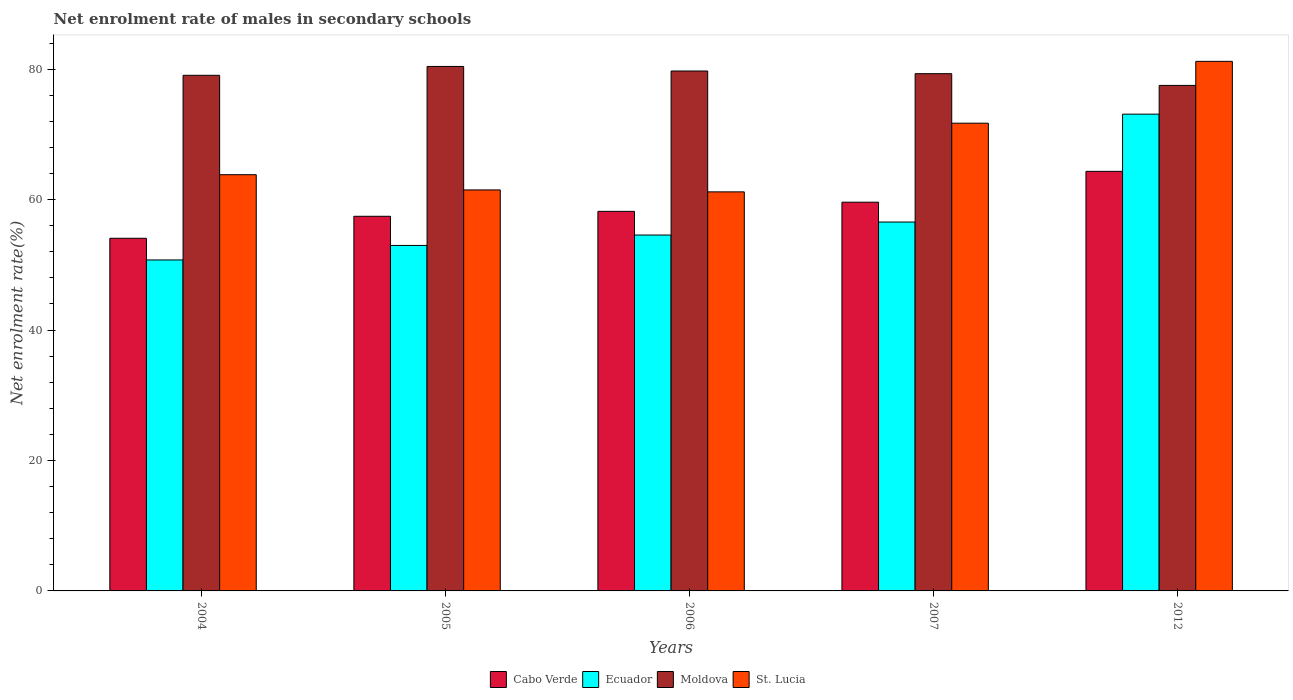Are the number of bars per tick equal to the number of legend labels?
Your answer should be compact. Yes. Are the number of bars on each tick of the X-axis equal?
Keep it short and to the point. Yes. How many bars are there on the 2nd tick from the left?
Give a very brief answer. 4. How many bars are there on the 2nd tick from the right?
Provide a succinct answer. 4. What is the label of the 4th group of bars from the left?
Keep it short and to the point. 2007. What is the net enrolment rate of males in secondary schools in St. Lucia in 2012?
Keep it short and to the point. 81.19. Across all years, what is the maximum net enrolment rate of males in secondary schools in Cabo Verde?
Your response must be concise. 64.33. Across all years, what is the minimum net enrolment rate of males in secondary schools in Moldova?
Your answer should be compact. 77.5. In which year was the net enrolment rate of males in secondary schools in Ecuador maximum?
Keep it short and to the point. 2012. In which year was the net enrolment rate of males in secondary schools in Cabo Verde minimum?
Provide a short and direct response. 2004. What is the total net enrolment rate of males in secondary schools in St. Lucia in the graph?
Provide a short and direct response. 339.38. What is the difference between the net enrolment rate of males in secondary schools in Moldova in 2005 and that in 2006?
Give a very brief answer. 0.7. What is the difference between the net enrolment rate of males in secondary schools in Ecuador in 2007 and the net enrolment rate of males in secondary schools in St. Lucia in 2006?
Give a very brief answer. -4.63. What is the average net enrolment rate of males in secondary schools in Moldova per year?
Offer a very short reply. 79.2. In the year 2007, what is the difference between the net enrolment rate of males in secondary schools in Cabo Verde and net enrolment rate of males in secondary schools in Moldova?
Give a very brief answer. -19.7. What is the ratio of the net enrolment rate of males in secondary schools in Moldova in 2004 to that in 2006?
Give a very brief answer. 0.99. What is the difference between the highest and the second highest net enrolment rate of males in secondary schools in Cabo Verde?
Your response must be concise. 4.73. What is the difference between the highest and the lowest net enrolment rate of males in secondary schools in Moldova?
Give a very brief answer. 2.91. Is the sum of the net enrolment rate of males in secondary schools in Cabo Verde in 2006 and 2012 greater than the maximum net enrolment rate of males in secondary schools in Ecuador across all years?
Provide a short and direct response. Yes. What does the 2nd bar from the left in 2007 represents?
Keep it short and to the point. Ecuador. What does the 3rd bar from the right in 2005 represents?
Keep it short and to the point. Ecuador. Is it the case that in every year, the sum of the net enrolment rate of males in secondary schools in Ecuador and net enrolment rate of males in secondary schools in Cabo Verde is greater than the net enrolment rate of males in secondary schools in St. Lucia?
Offer a very short reply. Yes. How many bars are there?
Provide a succinct answer. 20. Are all the bars in the graph horizontal?
Provide a short and direct response. No. Does the graph contain any zero values?
Keep it short and to the point. No. How many legend labels are there?
Keep it short and to the point. 4. What is the title of the graph?
Offer a very short reply. Net enrolment rate of males in secondary schools. What is the label or title of the Y-axis?
Make the answer very short. Net enrolment rate(%). What is the Net enrolment rate(%) of Cabo Verde in 2004?
Your answer should be very brief. 54.07. What is the Net enrolment rate(%) in Ecuador in 2004?
Offer a terse response. 50.74. What is the Net enrolment rate(%) in Moldova in 2004?
Keep it short and to the point. 79.05. What is the Net enrolment rate(%) of St. Lucia in 2004?
Give a very brief answer. 63.81. What is the Net enrolment rate(%) of Cabo Verde in 2005?
Your answer should be compact. 57.44. What is the Net enrolment rate(%) in Ecuador in 2005?
Provide a succinct answer. 52.97. What is the Net enrolment rate(%) of Moldova in 2005?
Offer a very short reply. 80.41. What is the Net enrolment rate(%) of St. Lucia in 2005?
Keep it short and to the point. 61.48. What is the Net enrolment rate(%) in Cabo Verde in 2006?
Your response must be concise. 58.19. What is the Net enrolment rate(%) of Ecuador in 2006?
Provide a short and direct response. 54.56. What is the Net enrolment rate(%) in Moldova in 2006?
Your answer should be compact. 79.71. What is the Net enrolment rate(%) of St. Lucia in 2006?
Your answer should be very brief. 61.18. What is the Net enrolment rate(%) in Cabo Verde in 2007?
Ensure brevity in your answer.  59.6. What is the Net enrolment rate(%) of Ecuador in 2007?
Your answer should be compact. 56.56. What is the Net enrolment rate(%) of Moldova in 2007?
Give a very brief answer. 79.3. What is the Net enrolment rate(%) of St. Lucia in 2007?
Your answer should be very brief. 71.71. What is the Net enrolment rate(%) of Cabo Verde in 2012?
Your answer should be compact. 64.33. What is the Net enrolment rate(%) in Ecuador in 2012?
Provide a short and direct response. 73.1. What is the Net enrolment rate(%) of Moldova in 2012?
Offer a terse response. 77.5. What is the Net enrolment rate(%) of St. Lucia in 2012?
Offer a very short reply. 81.19. Across all years, what is the maximum Net enrolment rate(%) of Cabo Verde?
Give a very brief answer. 64.33. Across all years, what is the maximum Net enrolment rate(%) in Ecuador?
Your answer should be very brief. 73.1. Across all years, what is the maximum Net enrolment rate(%) of Moldova?
Your answer should be very brief. 80.41. Across all years, what is the maximum Net enrolment rate(%) of St. Lucia?
Offer a terse response. 81.19. Across all years, what is the minimum Net enrolment rate(%) in Cabo Verde?
Your answer should be compact. 54.07. Across all years, what is the minimum Net enrolment rate(%) in Ecuador?
Your answer should be compact. 50.74. Across all years, what is the minimum Net enrolment rate(%) of Moldova?
Keep it short and to the point. 77.5. Across all years, what is the minimum Net enrolment rate(%) of St. Lucia?
Keep it short and to the point. 61.18. What is the total Net enrolment rate(%) in Cabo Verde in the graph?
Give a very brief answer. 293.62. What is the total Net enrolment rate(%) of Ecuador in the graph?
Keep it short and to the point. 287.93. What is the total Net enrolment rate(%) of Moldova in the graph?
Ensure brevity in your answer.  395.98. What is the total Net enrolment rate(%) of St. Lucia in the graph?
Offer a very short reply. 339.38. What is the difference between the Net enrolment rate(%) in Cabo Verde in 2004 and that in 2005?
Ensure brevity in your answer.  -3.37. What is the difference between the Net enrolment rate(%) of Ecuador in 2004 and that in 2005?
Ensure brevity in your answer.  -2.23. What is the difference between the Net enrolment rate(%) of Moldova in 2004 and that in 2005?
Keep it short and to the point. -1.36. What is the difference between the Net enrolment rate(%) of St. Lucia in 2004 and that in 2005?
Offer a very short reply. 2.33. What is the difference between the Net enrolment rate(%) in Cabo Verde in 2004 and that in 2006?
Offer a terse response. -4.13. What is the difference between the Net enrolment rate(%) in Ecuador in 2004 and that in 2006?
Provide a succinct answer. -3.82. What is the difference between the Net enrolment rate(%) of Moldova in 2004 and that in 2006?
Ensure brevity in your answer.  -0.66. What is the difference between the Net enrolment rate(%) of St. Lucia in 2004 and that in 2006?
Give a very brief answer. 2.63. What is the difference between the Net enrolment rate(%) in Cabo Verde in 2004 and that in 2007?
Your response must be concise. -5.53. What is the difference between the Net enrolment rate(%) of Ecuador in 2004 and that in 2007?
Your response must be concise. -5.81. What is the difference between the Net enrolment rate(%) in Moldova in 2004 and that in 2007?
Make the answer very short. -0.25. What is the difference between the Net enrolment rate(%) in St. Lucia in 2004 and that in 2007?
Your answer should be very brief. -7.9. What is the difference between the Net enrolment rate(%) of Cabo Verde in 2004 and that in 2012?
Provide a succinct answer. -10.26. What is the difference between the Net enrolment rate(%) in Ecuador in 2004 and that in 2012?
Ensure brevity in your answer.  -22.35. What is the difference between the Net enrolment rate(%) of Moldova in 2004 and that in 2012?
Keep it short and to the point. 1.55. What is the difference between the Net enrolment rate(%) of St. Lucia in 2004 and that in 2012?
Provide a short and direct response. -17.38. What is the difference between the Net enrolment rate(%) of Cabo Verde in 2005 and that in 2006?
Your answer should be compact. -0.76. What is the difference between the Net enrolment rate(%) of Ecuador in 2005 and that in 2006?
Give a very brief answer. -1.59. What is the difference between the Net enrolment rate(%) in Moldova in 2005 and that in 2006?
Ensure brevity in your answer.  0.7. What is the difference between the Net enrolment rate(%) of St. Lucia in 2005 and that in 2006?
Give a very brief answer. 0.3. What is the difference between the Net enrolment rate(%) of Cabo Verde in 2005 and that in 2007?
Provide a short and direct response. -2.16. What is the difference between the Net enrolment rate(%) of Ecuador in 2005 and that in 2007?
Your answer should be very brief. -3.59. What is the difference between the Net enrolment rate(%) of Moldova in 2005 and that in 2007?
Provide a succinct answer. 1.11. What is the difference between the Net enrolment rate(%) in St. Lucia in 2005 and that in 2007?
Your answer should be very brief. -10.23. What is the difference between the Net enrolment rate(%) in Cabo Verde in 2005 and that in 2012?
Your answer should be very brief. -6.89. What is the difference between the Net enrolment rate(%) in Ecuador in 2005 and that in 2012?
Your response must be concise. -20.13. What is the difference between the Net enrolment rate(%) in Moldova in 2005 and that in 2012?
Offer a terse response. 2.91. What is the difference between the Net enrolment rate(%) in St. Lucia in 2005 and that in 2012?
Ensure brevity in your answer.  -19.71. What is the difference between the Net enrolment rate(%) of Cabo Verde in 2006 and that in 2007?
Keep it short and to the point. -1.4. What is the difference between the Net enrolment rate(%) of Ecuador in 2006 and that in 2007?
Provide a short and direct response. -1.99. What is the difference between the Net enrolment rate(%) of Moldova in 2006 and that in 2007?
Make the answer very short. 0.41. What is the difference between the Net enrolment rate(%) in St. Lucia in 2006 and that in 2007?
Your response must be concise. -10.53. What is the difference between the Net enrolment rate(%) of Cabo Verde in 2006 and that in 2012?
Provide a succinct answer. -6.13. What is the difference between the Net enrolment rate(%) in Ecuador in 2006 and that in 2012?
Offer a terse response. -18.54. What is the difference between the Net enrolment rate(%) of Moldova in 2006 and that in 2012?
Provide a short and direct response. 2.21. What is the difference between the Net enrolment rate(%) of St. Lucia in 2006 and that in 2012?
Keep it short and to the point. -20.01. What is the difference between the Net enrolment rate(%) of Cabo Verde in 2007 and that in 2012?
Offer a very short reply. -4.73. What is the difference between the Net enrolment rate(%) of Ecuador in 2007 and that in 2012?
Ensure brevity in your answer.  -16.54. What is the difference between the Net enrolment rate(%) in Moldova in 2007 and that in 2012?
Make the answer very short. 1.8. What is the difference between the Net enrolment rate(%) in St. Lucia in 2007 and that in 2012?
Provide a succinct answer. -9.48. What is the difference between the Net enrolment rate(%) of Cabo Verde in 2004 and the Net enrolment rate(%) of Ecuador in 2005?
Your answer should be compact. 1.1. What is the difference between the Net enrolment rate(%) in Cabo Verde in 2004 and the Net enrolment rate(%) in Moldova in 2005?
Ensure brevity in your answer.  -26.34. What is the difference between the Net enrolment rate(%) of Cabo Verde in 2004 and the Net enrolment rate(%) of St. Lucia in 2005?
Provide a succinct answer. -7.41. What is the difference between the Net enrolment rate(%) of Ecuador in 2004 and the Net enrolment rate(%) of Moldova in 2005?
Provide a succinct answer. -29.67. What is the difference between the Net enrolment rate(%) of Ecuador in 2004 and the Net enrolment rate(%) of St. Lucia in 2005?
Provide a succinct answer. -10.74. What is the difference between the Net enrolment rate(%) of Moldova in 2004 and the Net enrolment rate(%) of St. Lucia in 2005?
Provide a succinct answer. 17.57. What is the difference between the Net enrolment rate(%) in Cabo Verde in 2004 and the Net enrolment rate(%) in Ecuador in 2006?
Provide a succinct answer. -0.5. What is the difference between the Net enrolment rate(%) in Cabo Verde in 2004 and the Net enrolment rate(%) in Moldova in 2006?
Your answer should be compact. -25.64. What is the difference between the Net enrolment rate(%) of Cabo Verde in 2004 and the Net enrolment rate(%) of St. Lucia in 2006?
Your answer should be compact. -7.12. What is the difference between the Net enrolment rate(%) in Ecuador in 2004 and the Net enrolment rate(%) in Moldova in 2006?
Your answer should be compact. -28.97. What is the difference between the Net enrolment rate(%) in Ecuador in 2004 and the Net enrolment rate(%) in St. Lucia in 2006?
Keep it short and to the point. -10.44. What is the difference between the Net enrolment rate(%) of Moldova in 2004 and the Net enrolment rate(%) of St. Lucia in 2006?
Offer a terse response. 17.87. What is the difference between the Net enrolment rate(%) in Cabo Verde in 2004 and the Net enrolment rate(%) in Ecuador in 2007?
Give a very brief answer. -2.49. What is the difference between the Net enrolment rate(%) in Cabo Verde in 2004 and the Net enrolment rate(%) in Moldova in 2007?
Give a very brief answer. -25.23. What is the difference between the Net enrolment rate(%) of Cabo Verde in 2004 and the Net enrolment rate(%) of St. Lucia in 2007?
Provide a succinct answer. -17.64. What is the difference between the Net enrolment rate(%) in Ecuador in 2004 and the Net enrolment rate(%) in Moldova in 2007?
Provide a short and direct response. -28.56. What is the difference between the Net enrolment rate(%) in Ecuador in 2004 and the Net enrolment rate(%) in St. Lucia in 2007?
Keep it short and to the point. -20.97. What is the difference between the Net enrolment rate(%) in Moldova in 2004 and the Net enrolment rate(%) in St. Lucia in 2007?
Your answer should be very brief. 7.34. What is the difference between the Net enrolment rate(%) of Cabo Verde in 2004 and the Net enrolment rate(%) of Ecuador in 2012?
Provide a short and direct response. -19.03. What is the difference between the Net enrolment rate(%) of Cabo Verde in 2004 and the Net enrolment rate(%) of Moldova in 2012?
Your answer should be very brief. -23.44. What is the difference between the Net enrolment rate(%) in Cabo Verde in 2004 and the Net enrolment rate(%) in St. Lucia in 2012?
Make the answer very short. -27.13. What is the difference between the Net enrolment rate(%) in Ecuador in 2004 and the Net enrolment rate(%) in Moldova in 2012?
Your answer should be compact. -26.76. What is the difference between the Net enrolment rate(%) in Ecuador in 2004 and the Net enrolment rate(%) in St. Lucia in 2012?
Ensure brevity in your answer.  -30.45. What is the difference between the Net enrolment rate(%) of Moldova in 2004 and the Net enrolment rate(%) of St. Lucia in 2012?
Offer a terse response. -2.14. What is the difference between the Net enrolment rate(%) of Cabo Verde in 2005 and the Net enrolment rate(%) of Ecuador in 2006?
Keep it short and to the point. 2.88. What is the difference between the Net enrolment rate(%) in Cabo Verde in 2005 and the Net enrolment rate(%) in Moldova in 2006?
Your answer should be very brief. -22.27. What is the difference between the Net enrolment rate(%) of Cabo Verde in 2005 and the Net enrolment rate(%) of St. Lucia in 2006?
Your response must be concise. -3.75. What is the difference between the Net enrolment rate(%) of Ecuador in 2005 and the Net enrolment rate(%) of Moldova in 2006?
Give a very brief answer. -26.74. What is the difference between the Net enrolment rate(%) of Ecuador in 2005 and the Net enrolment rate(%) of St. Lucia in 2006?
Keep it short and to the point. -8.21. What is the difference between the Net enrolment rate(%) of Moldova in 2005 and the Net enrolment rate(%) of St. Lucia in 2006?
Provide a succinct answer. 19.23. What is the difference between the Net enrolment rate(%) in Cabo Verde in 2005 and the Net enrolment rate(%) in Ecuador in 2007?
Make the answer very short. 0.88. What is the difference between the Net enrolment rate(%) of Cabo Verde in 2005 and the Net enrolment rate(%) of Moldova in 2007?
Provide a short and direct response. -21.86. What is the difference between the Net enrolment rate(%) of Cabo Verde in 2005 and the Net enrolment rate(%) of St. Lucia in 2007?
Provide a succinct answer. -14.27. What is the difference between the Net enrolment rate(%) of Ecuador in 2005 and the Net enrolment rate(%) of Moldova in 2007?
Your answer should be very brief. -26.33. What is the difference between the Net enrolment rate(%) in Ecuador in 2005 and the Net enrolment rate(%) in St. Lucia in 2007?
Your answer should be compact. -18.74. What is the difference between the Net enrolment rate(%) of Moldova in 2005 and the Net enrolment rate(%) of St. Lucia in 2007?
Your answer should be compact. 8.7. What is the difference between the Net enrolment rate(%) in Cabo Verde in 2005 and the Net enrolment rate(%) in Ecuador in 2012?
Offer a very short reply. -15.66. What is the difference between the Net enrolment rate(%) in Cabo Verde in 2005 and the Net enrolment rate(%) in Moldova in 2012?
Give a very brief answer. -20.07. What is the difference between the Net enrolment rate(%) of Cabo Verde in 2005 and the Net enrolment rate(%) of St. Lucia in 2012?
Provide a short and direct response. -23.75. What is the difference between the Net enrolment rate(%) in Ecuador in 2005 and the Net enrolment rate(%) in Moldova in 2012?
Offer a very short reply. -24.53. What is the difference between the Net enrolment rate(%) in Ecuador in 2005 and the Net enrolment rate(%) in St. Lucia in 2012?
Your answer should be compact. -28.22. What is the difference between the Net enrolment rate(%) in Moldova in 2005 and the Net enrolment rate(%) in St. Lucia in 2012?
Your answer should be very brief. -0.78. What is the difference between the Net enrolment rate(%) in Cabo Verde in 2006 and the Net enrolment rate(%) in Ecuador in 2007?
Ensure brevity in your answer.  1.64. What is the difference between the Net enrolment rate(%) of Cabo Verde in 2006 and the Net enrolment rate(%) of Moldova in 2007?
Offer a terse response. -21.11. What is the difference between the Net enrolment rate(%) of Cabo Verde in 2006 and the Net enrolment rate(%) of St. Lucia in 2007?
Keep it short and to the point. -13.52. What is the difference between the Net enrolment rate(%) of Ecuador in 2006 and the Net enrolment rate(%) of Moldova in 2007?
Provide a short and direct response. -24.74. What is the difference between the Net enrolment rate(%) of Ecuador in 2006 and the Net enrolment rate(%) of St. Lucia in 2007?
Your answer should be compact. -17.15. What is the difference between the Net enrolment rate(%) in Moldova in 2006 and the Net enrolment rate(%) in St. Lucia in 2007?
Give a very brief answer. 8. What is the difference between the Net enrolment rate(%) of Cabo Verde in 2006 and the Net enrolment rate(%) of Ecuador in 2012?
Give a very brief answer. -14.9. What is the difference between the Net enrolment rate(%) in Cabo Verde in 2006 and the Net enrolment rate(%) in Moldova in 2012?
Give a very brief answer. -19.31. What is the difference between the Net enrolment rate(%) in Cabo Verde in 2006 and the Net enrolment rate(%) in St. Lucia in 2012?
Make the answer very short. -23. What is the difference between the Net enrolment rate(%) in Ecuador in 2006 and the Net enrolment rate(%) in Moldova in 2012?
Your response must be concise. -22.94. What is the difference between the Net enrolment rate(%) in Ecuador in 2006 and the Net enrolment rate(%) in St. Lucia in 2012?
Your answer should be very brief. -26.63. What is the difference between the Net enrolment rate(%) in Moldova in 2006 and the Net enrolment rate(%) in St. Lucia in 2012?
Your answer should be very brief. -1.48. What is the difference between the Net enrolment rate(%) in Cabo Verde in 2007 and the Net enrolment rate(%) in Ecuador in 2012?
Your answer should be very brief. -13.5. What is the difference between the Net enrolment rate(%) in Cabo Verde in 2007 and the Net enrolment rate(%) in Moldova in 2012?
Your answer should be compact. -17.91. What is the difference between the Net enrolment rate(%) in Cabo Verde in 2007 and the Net enrolment rate(%) in St. Lucia in 2012?
Ensure brevity in your answer.  -21.59. What is the difference between the Net enrolment rate(%) in Ecuador in 2007 and the Net enrolment rate(%) in Moldova in 2012?
Give a very brief answer. -20.95. What is the difference between the Net enrolment rate(%) in Ecuador in 2007 and the Net enrolment rate(%) in St. Lucia in 2012?
Provide a succinct answer. -24.64. What is the difference between the Net enrolment rate(%) of Moldova in 2007 and the Net enrolment rate(%) of St. Lucia in 2012?
Provide a short and direct response. -1.89. What is the average Net enrolment rate(%) in Cabo Verde per year?
Your response must be concise. 58.72. What is the average Net enrolment rate(%) of Ecuador per year?
Keep it short and to the point. 57.59. What is the average Net enrolment rate(%) in Moldova per year?
Your answer should be compact. 79.2. What is the average Net enrolment rate(%) in St. Lucia per year?
Your answer should be very brief. 67.88. In the year 2004, what is the difference between the Net enrolment rate(%) in Cabo Verde and Net enrolment rate(%) in Ecuador?
Provide a short and direct response. 3.32. In the year 2004, what is the difference between the Net enrolment rate(%) of Cabo Verde and Net enrolment rate(%) of Moldova?
Provide a succinct answer. -24.99. In the year 2004, what is the difference between the Net enrolment rate(%) in Cabo Verde and Net enrolment rate(%) in St. Lucia?
Ensure brevity in your answer.  -9.75. In the year 2004, what is the difference between the Net enrolment rate(%) of Ecuador and Net enrolment rate(%) of Moldova?
Make the answer very short. -28.31. In the year 2004, what is the difference between the Net enrolment rate(%) of Ecuador and Net enrolment rate(%) of St. Lucia?
Make the answer very short. -13.07. In the year 2004, what is the difference between the Net enrolment rate(%) in Moldova and Net enrolment rate(%) in St. Lucia?
Provide a short and direct response. 15.24. In the year 2005, what is the difference between the Net enrolment rate(%) of Cabo Verde and Net enrolment rate(%) of Ecuador?
Provide a short and direct response. 4.47. In the year 2005, what is the difference between the Net enrolment rate(%) of Cabo Verde and Net enrolment rate(%) of Moldova?
Provide a short and direct response. -22.97. In the year 2005, what is the difference between the Net enrolment rate(%) of Cabo Verde and Net enrolment rate(%) of St. Lucia?
Your response must be concise. -4.04. In the year 2005, what is the difference between the Net enrolment rate(%) of Ecuador and Net enrolment rate(%) of Moldova?
Ensure brevity in your answer.  -27.44. In the year 2005, what is the difference between the Net enrolment rate(%) of Ecuador and Net enrolment rate(%) of St. Lucia?
Your response must be concise. -8.51. In the year 2005, what is the difference between the Net enrolment rate(%) in Moldova and Net enrolment rate(%) in St. Lucia?
Offer a very short reply. 18.93. In the year 2006, what is the difference between the Net enrolment rate(%) of Cabo Verde and Net enrolment rate(%) of Ecuador?
Provide a short and direct response. 3.63. In the year 2006, what is the difference between the Net enrolment rate(%) in Cabo Verde and Net enrolment rate(%) in Moldova?
Make the answer very short. -21.52. In the year 2006, what is the difference between the Net enrolment rate(%) of Cabo Verde and Net enrolment rate(%) of St. Lucia?
Provide a succinct answer. -2.99. In the year 2006, what is the difference between the Net enrolment rate(%) of Ecuador and Net enrolment rate(%) of Moldova?
Offer a terse response. -25.15. In the year 2006, what is the difference between the Net enrolment rate(%) of Ecuador and Net enrolment rate(%) of St. Lucia?
Ensure brevity in your answer.  -6.62. In the year 2006, what is the difference between the Net enrolment rate(%) of Moldova and Net enrolment rate(%) of St. Lucia?
Offer a very short reply. 18.53. In the year 2007, what is the difference between the Net enrolment rate(%) in Cabo Verde and Net enrolment rate(%) in Ecuador?
Provide a succinct answer. 3.04. In the year 2007, what is the difference between the Net enrolment rate(%) in Cabo Verde and Net enrolment rate(%) in Moldova?
Keep it short and to the point. -19.7. In the year 2007, what is the difference between the Net enrolment rate(%) of Cabo Verde and Net enrolment rate(%) of St. Lucia?
Your answer should be compact. -12.11. In the year 2007, what is the difference between the Net enrolment rate(%) in Ecuador and Net enrolment rate(%) in Moldova?
Offer a terse response. -22.75. In the year 2007, what is the difference between the Net enrolment rate(%) in Ecuador and Net enrolment rate(%) in St. Lucia?
Give a very brief answer. -15.15. In the year 2007, what is the difference between the Net enrolment rate(%) of Moldova and Net enrolment rate(%) of St. Lucia?
Your answer should be compact. 7.59. In the year 2012, what is the difference between the Net enrolment rate(%) of Cabo Verde and Net enrolment rate(%) of Ecuador?
Keep it short and to the point. -8.77. In the year 2012, what is the difference between the Net enrolment rate(%) of Cabo Verde and Net enrolment rate(%) of Moldova?
Give a very brief answer. -13.18. In the year 2012, what is the difference between the Net enrolment rate(%) in Cabo Verde and Net enrolment rate(%) in St. Lucia?
Your answer should be compact. -16.86. In the year 2012, what is the difference between the Net enrolment rate(%) of Ecuador and Net enrolment rate(%) of Moldova?
Offer a very short reply. -4.41. In the year 2012, what is the difference between the Net enrolment rate(%) of Ecuador and Net enrolment rate(%) of St. Lucia?
Keep it short and to the point. -8.09. In the year 2012, what is the difference between the Net enrolment rate(%) in Moldova and Net enrolment rate(%) in St. Lucia?
Give a very brief answer. -3.69. What is the ratio of the Net enrolment rate(%) in Cabo Verde in 2004 to that in 2005?
Your response must be concise. 0.94. What is the ratio of the Net enrolment rate(%) of Ecuador in 2004 to that in 2005?
Ensure brevity in your answer.  0.96. What is the ratio of the Net enrolment rate(%) of Moldova in 2004 to that in 2005?
Provide a short and direct response. 0.98. What is the ratio of the Net enrolment rate(%) in St. Lucia in 2004 to that in 2005?
Your answer should be very brief. 1.04. What is the ratio of the Net enrolment rate(%) in Cabo Verde in 2004 to that in 2006?
Your answer should be very brief. 0.93. What is the ratio of the Net enrolment rate(%) of Moldova in 2004 to that in 2006?
Give a very brief answer. 0.99. What is the ratio of the Net enrolment rate(%) of St. Lucia in 2004 to that in 2006?
Your answer should be very brief. 1.04. What is the ratio of the Net enrolment rate(%) of Cabo Verde in 2004 to that in 2007?
Your answer should be compact. 0.91. What is the ratio of the Net enrolment rate(%) of Ecuador in 2004 to that in 2007?
Offer a terse response. 0.9. What is the ratio of the Net enrolment rate(%) in Moldova in 2004 to that in 2007?
Your answer should be compact. 1. What is the ratio of the Net enrolment rate(%) of St. Lucia in 2004 to that in 2007?
Give a very brief answer. 0.89. What is the ratio of the Net enrolment rate(%) in Cabo Verde in 2004 to that in 2012?
Make the answer very short. 0.84. What is the ratio of the Net enrolment rate(%) in Ecuador in 2004 to that in 2012?
Your response must be concise. 0.69. What is the ratio of the Net enrolment rate(%) in Moldova in 2004 to that in 2012?
Your answer should be compact. 1.02. What is the ratio of the Net enrolment rate(%) of St. Lucia in 2004 to that in 2012?
Provide a short and direct response. 0.79. What is the ratio of the Net enrolment rate(%) of Ecuador in 2005 to that in 2006?
Ensure brevity in your answer.  0.97. What is the ratio of the Net enrolment rate(%) in Moldova in 2005 to that in 2006?
Ensure brevity in your answer.  1.01. What is the ratio of the Net enrolment rate(%) of Cabo Verde in 2005 to that in 2007?
Make the answer very short. 0.96. What is the ratio of the Net enrolment rate(%) of Ecuador in 2005 to that in 2007?
Ensure brevity in your answer.  0.94. What is the ratio of the Net enrolment rate(%) of St. Lucia in 2005 to that in 2007?
Ensure brevity in your answer.  0.86. What is the ratio of the Net enrolment rate(%) in Cabo Verde in 2005 to that in 2012?
Provide a short and direct response. 0.89. What is the ratio of the Net enrolment rate(%) of Ecuador in 2005 to that in 2012?
Provide a succinct answer. 0.72. What is the ratio of the Net enrolment rate(%) of Moldova in 2005 to that in 2012?
Offer a very short reply. 1.04. What is the ratio of the Net enrolment rate(%) of St. Lucia in 2005 to that in 2012?
Provide a short and direct response. 0.76. What is the ratio of the Net enrolment rate(%) in Cabo Verde in 2006 to that in 2007?
Offer a very short reply. 0.98. What is the ratio of the Net enrolment rate(%) of Ecuador in 2006 to that in 2007?
Offer a very short reply. 0.96. What is the ratio of the Net enrolment rate(%) of Moldova in 2006 to that in 2007?
Make the answer very short. 1.01. What is the ratio of the Net enrolment rate(%) of St. Lucia in 2006 to that in 2007?
Your answer should be very brief. 0.85. What is the ratio of the Net enrolment rate(%) of Cabo Verde in 2006 to that in 2012?
Give a very brief answer. 0.9. What is the ratio of the Net enrolment rate(%) of Ecuador in 2006 to that in 2012?
Provide a succinct answer. 0.75. What is the ratio of the Net enrolment rate(%) in Moldova in 2006 to that in 2012?
Your answer should be very brief. 1.03. What is the ratio of the Net enrolment rate(%) in St. Lucia in 2006 to that in 2012?
Offer a very short reply. 0.75. What is the ratio of the Net enrolment rate(%) of Cabo Verde in 2007 to that in 2012?
Keep it short and to the point. 0.93. What is the ratio of the Net enrolment rate(%) in Ecuador in 2007 to that in 2012?
Your answer should be compact. 0.77. What is the ratio of the Net enrolment rate(%) of Moldova in 2007 to that in 2012?
Provide a short and direct response. 1.02. What is the ratio of the Net enrolment rate(%) in St. Lucia in 2007 to that in 2012?
Your answer should be very brief. 0.88. What is the difference between the highest and the second highest Net enrolment rate(%) of Cabo Verde?
Your response must be concise. 4.73. What is the difference between the highest and the second highest Net enrolment rate(%) in Ecuador?
Make the answer very short. 16.54. What is the difference between the highest and the second highest Net enrolment rate(%) of Moldova?
Your answer should be compact. 0.7. What is the difference between the highest and the second highest Net enrolment rate(%) of St. Lucia?
Ensure brevity in your answer.  9.48. What is the difference between the highest and the lowest Net enrolment rate(%) in Cabo Verde?
Offer a very short reply. 10.26. What is the difference between the highest and the lowest Net enrolment rate(%) in Ecuador?
Provide a succinct answer. 22.35. What is the difference between the highest and the lowest Net enrolment rate(%) of Moldova?
Your answer should be compact. 2.91. What is the difference between the highest and the lowest Net enrolment rate(%) of St. Lucia?
Your answer should be compact. 20.01. 